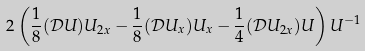<formula> <loc_0><loc_0><loc_500><loc_500>2 \left ( \frac { 1 } { 8 } ( \mathcal { D } U ) U _ { 2 x } - \frac { 1 } { 8 } ( \mathcal { D } U _ { x } ) U _ { x } - \frac { 1 } { 4 } ( \mathcal { D } U _ { 2 x } ) U \right ) U ^ { - 1 }</formula> 